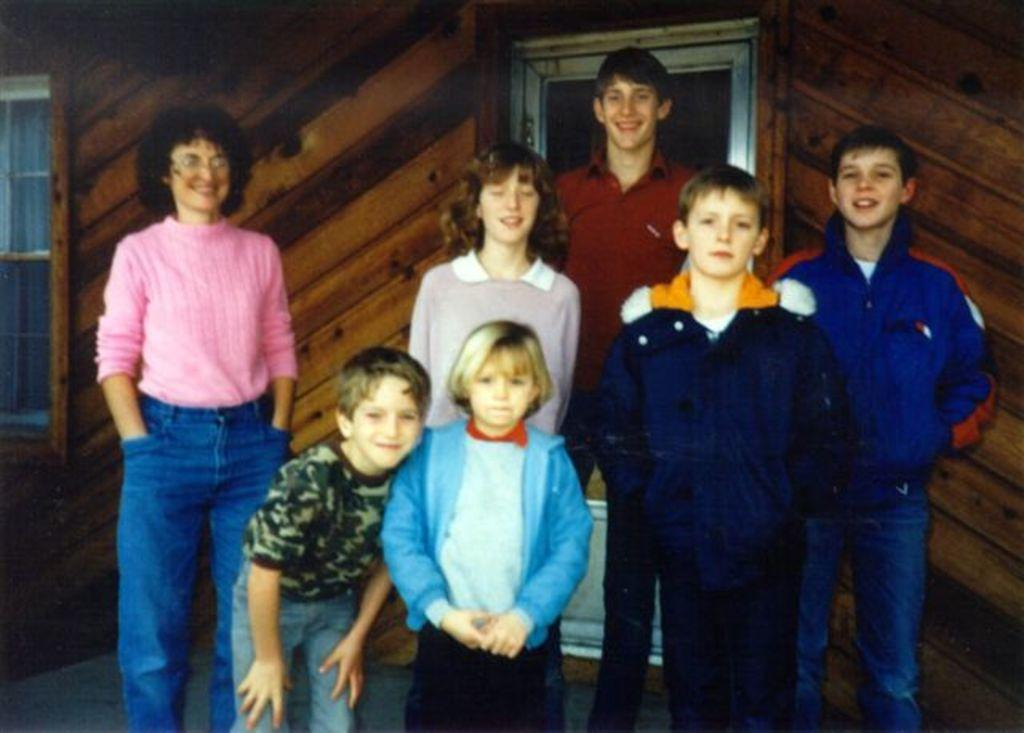How many people are in the image? There is a group of people in the image. Where are the people located in the image? The people are standing on a path. What type of structure is visible in the image? There is a wooden wall in the image. What features does the wooden wall have? The wooden wall has a door and a window. What type of cap is the fact wearing in the image? There is no cap or fact present in the image; it features a group of people standing on a path with a wooden wall that has a door and a window. 